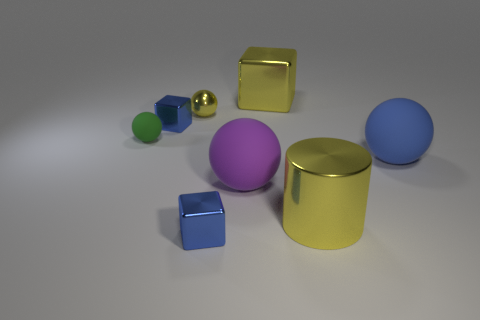Subtract all blue blocks. How many were subtracted if there are1blue blocks left? 1 Add 1 purple rubber things. How many objects exist? 9 Subtract all cylinders. How many objects are left? 7 Subtract 0 green blocks. How many objects are left? 8 Subtract all large cyan cylinders. Subtract all tiny metal things. How many objects are left? 5 Add 7 yellow cubes. How many yellow cubes are left? 8 Add 7 big yellow shiny cylinders. How many big yellow shiny cylinders exist? 8 